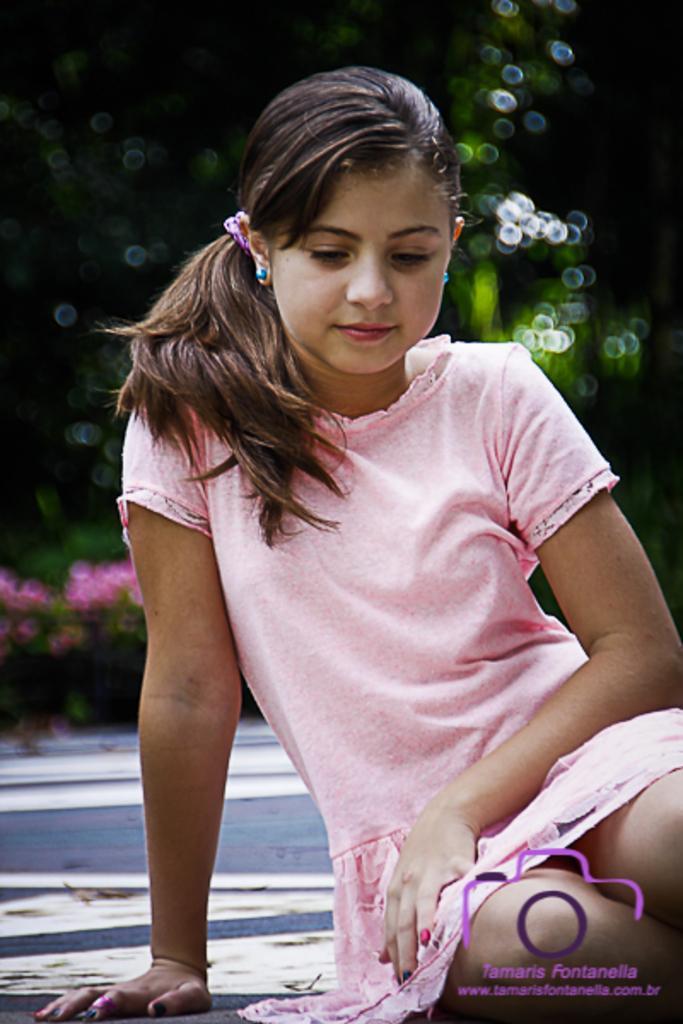How would you summarize this image in a sentence or two? In the front of the image we can see a girl. In the background it is blur. At the bottom right side of the image there is a watermark. 